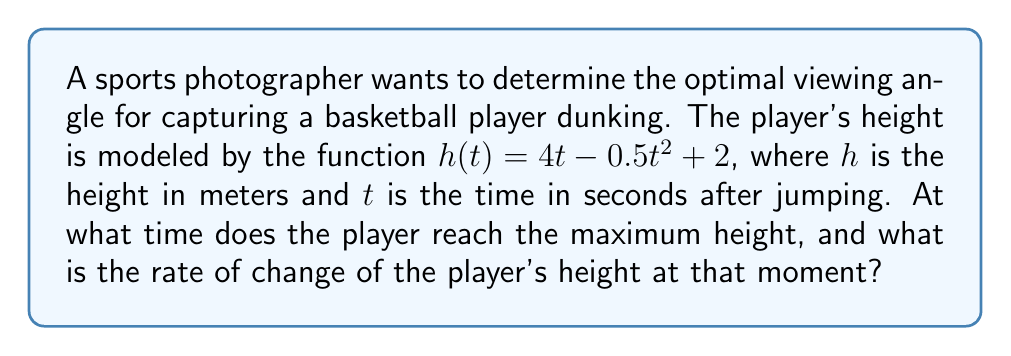Help me with this question. 1. To find the time when the player reaches maximum height, we need to find the critical point of the function $h(t)$. This occurs when the derivative $h'(t) = 0$.

2. Let's find the derivative of $h(t)$:
   $$h'(t) = 4 - t$$

3. Set $h'(t) = 0$ and solve for $t$:
   $$4 - t = 0$$
   $$t = 4$$

4. This critical point at $t = 4$ seconds represents the time when the player reaches maximum height.

5. To find the rate of change at this moment, we need to evaluate the second derivative at $t = 4$:
   $$h''(t) = -1$$

6. Since $h''(t)$ is always negative, the critical point at $t = 4$ is indeed a maximum.

7. The rate of change at the maximum height is given by $h'(4)$:
   $$h'(4) = 4 - 4 = 0$$

This makes sense because, at the maximum height, the player's vertical velocity is momentarily zero before they start descending.
Answer: Maximum height at $t = 4$ seconds; Rate of change at maximum height: $0$ m/s 